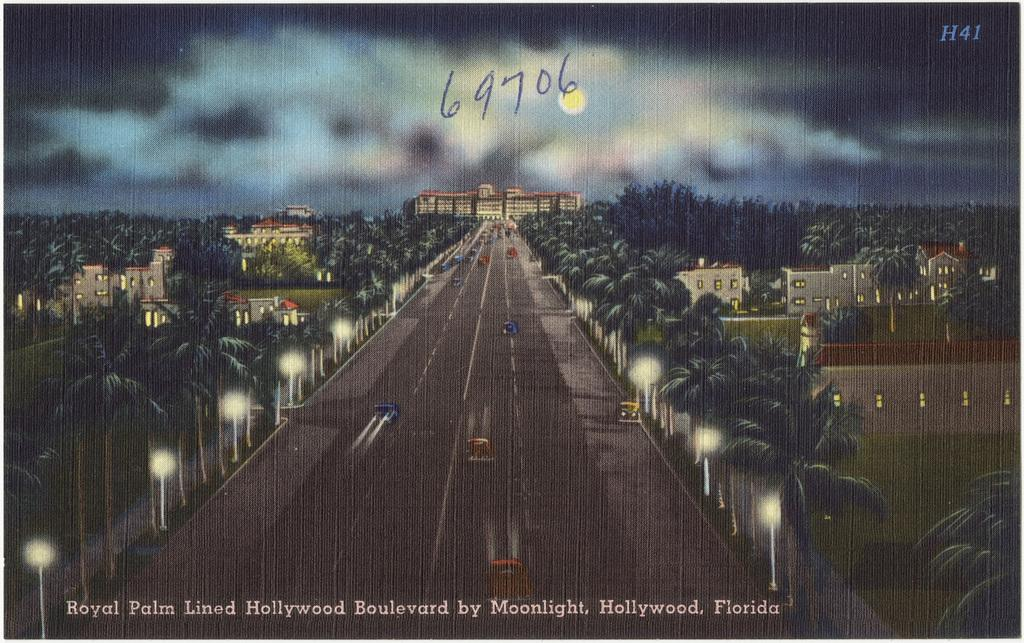What type of landscape is depicted in the painting? The painting contains trees and buildings, suggesting a landscape with both natural and man-made elements. What can be seen illuminated in the painting? The painting contains lights, which may indicate that certain areas or objects are highlighted or visible at night. What type of transportation is present in the painting? The painting contains vehicles on the road, suggesting a scene with traffic or movement. What is written at the bottom of the painting? There is text written at the bottom of the painting, which could provide additional information or context about the scene. How many apples are hanging from the trees in the painting? There is no mention of apples in the painting; it contains trees and buildings. What type of stretch is depicted in the painting? There is no stretch depicted in the painting; it contains lights, vehicles, and text. 